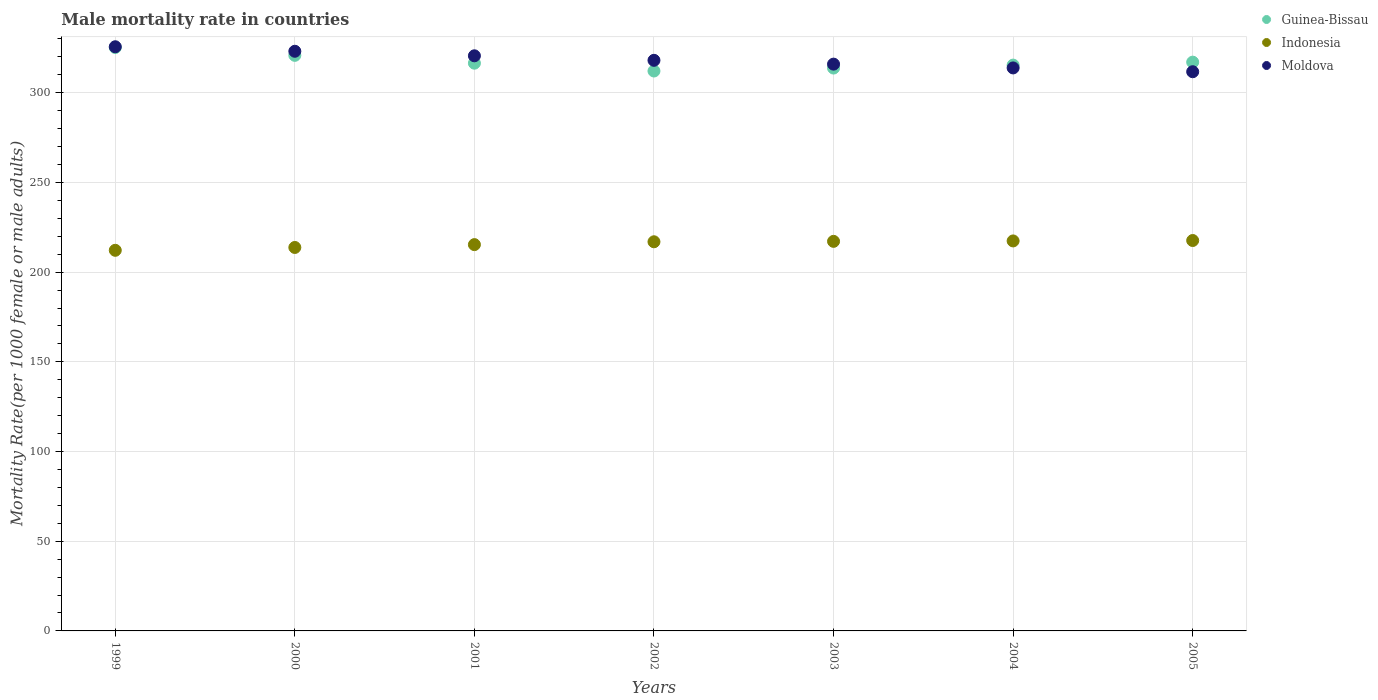Is the number of dotlines equal to the number of legend labels?
Provide a succinct answer. Yes. What is the male mortality rate in Indonesia in 2005?
Ensure brevity in your answer.  217.65. Across all years, what is the maximum male mortality rate in Indonesia?
Provide a short and direct response. 217.65. Across all years, what is the minimum male mortality rate in Indonesia?
Keep it short and to the point. 212.19. What is the total male mortality rate in Indonesia in the graph?
Provide a succinct answer. 1510.49. What is the difference between the male mortality rate in Guinea-Bissau in 2001 and that in 2005?
Provide a succinct answer. -0.57. What is the difference between the male mortality rate in Indonesia in 2004 and the male mortality rate in Moldova in 2001?
Offer a very short reply. -103.21. What is the average male mortality rate in Moldova per year?
Keep it short and to the point. 318.44. In the year 2000, what is the difference between the male mortality rate in Moldova and male mortality rate in Guinea-Bissau?
Provide a succinct answer. 2.27. What is the ratio of the male mortality rate in Moldova in 2002 to that in 2004?
Your answer should be very brief. 1.01. Is the difference between the male mortality rate in Moldova in 2002 and 2004 greater than the difference between the male mortality rate in Guinea-Bissau in 2002 and 2004?
Provide a short and direct response. Yes. What is the difference between the highest and the second highest male mortality rate in Guinea-Bissau?
Ensure brevity in your answer.  4.37. What is the difference between the highest and the lowest male mortality rate in Guinea-Bissau?
Your answer should be compact. 13.1. In how many years, is the male mortality rate in Indonesia greater than the average male mortality rate in Indonesia taken over all years?
Ensure brevity in your answer.  4. Is the sum of the male mortality rate in Moldova in 2004 and 2005 greater than the maximum male mortality rate in Guinea-Bissau across all years?
Provide a short and direct response. Yes. Does the male mortality rate in Indonesia monotonically increase over the years?
Provide a short and direct response. Yes. What is the difference between two consecutive major ticks on the Y-axis?
Ensure brevity in your answer.  50. Does the graph contain any zero values?
Offer a terse response. No. How are the legend labels stacked?
Make the answer very short. Vertical. What is the title of the graph?
Offer a terse response. Male mortality rate in countries. Does "South Sudan" appear as one of the legend labels in the graph?
Your answer should be compact. No. What is the label or title of the Y-axis?
Provide a succinct answer. Mortality Rate(per 1000 female or male adults). What is the Mortality Rate(per 1000 female or male adults) of Guinea-Bissau in 1999?
Provide a short and direct response. 325.23. What is the Mortality Rate(per 1000 female or male adults) in Indonesia in 1999?
Provide a succinct answer. 212.19. What is the Mortality Rate(per 1000 female or male adults) of Moldova in 1999?
Your answer should be very brief. 325.66. What is the Mortality Rate(per 1000 female or male adults) in Guinea-Bissau in 2000?
Provide a succinct answer. 320.87. What is the Mortality Rate(per 1000 female or male adults) in Indonesia in 2000?
Your response must be concise. 213.77. What is the Mortality Rate(per 1000 female or male adults) in Moldova in 2000?
Your answer should be compact. 323.14. What is the Mortality Rate(per 1000 female or male adults) in Guinea-Bissau in 2001?
Keep it short and to the point. 316.5. What is the Mortality Rate(per 1000 female or male adults) of Indonesia in 2001?
Provide a succinct answer. 215.36. What is the Mortality Rate(per 1000 female or male adults) of Moldova in 2001?
Ensure brevity in your answer.  320.62. What is the Mortality Rate(per 1000 female or male adults) in Guinea-Bissau in 2002?
Your answer should be very brief. 312.14. What is the Mortality Rate(per 1000 female or male adults) of Indonesia in 2002?
Offer a terse response. 216.94. What is the Mortality Rate(per 1000 female or male adults) in Moldova in 2002?
Make the answer very short. 318.1. What is the Mortality Rate(per 1000 female or male adults) in Guinea-Bissau in 2003?
Give a very brief answer. 313.79. What is the Mortality Rate(per 1000 female or male adults) in Indonesia in 2003?
Provide a succinct answer. 217.18. What is the Mortality Rate(per 1000 female or male adults) of Moldova in 2003?
Ensure brevity in your answer.  315.98. What is the Mortality Rate(per 1000 female or male adults) of Guinea-Bissau in 2004?
Your response must be concise. 315.43. What is the Mortality Rate(per 1000 female or male adults) in Indonesia in 2004?
Give a very brief answer. 217.41. What is the Mortality Rate(per 1000 female or male adults) of Moldova in 2004?
Offer a terse response. 313.86. What is the Mortality Rate(per 1000 female or male adults) of Guinea-Bissau in 2005?
Your response must be concise. 317.08. What is the Mortality Rate(per 1000 female or male adults) in Indonesia in 2005?
Your answer should be compact. 217.65. What is the Mortality Rate(per 1000 female or male adults) of Moldova in 2005?
Your answer should be very brief. 311.74. Across all years, what is the maximum Mortality Rate(per 1000 female or male adults) in Guinea-Bissau?
Your answer should be compact. 325.23. Across all years, what is the maximum Mortality Rate(per 1000 female or male adults) in Indonesia?
Your response must be concise. 217.65. Across all years, what is the maximum Mortality Rate(per 1000 female or male adults) in Moldova?
Make the answer very short. 325.66. Across all years, what is the minimum Mortality Rate(per 1000 female or male adults) in Guinea-Bissau?
Make the answer very short. 312.14. Across all years, what is the minimum Mortality Rate(per 1000 female or male adults) in Indonesia?
Offer a very short reply. 212.19. Across all years, what is the minimum Mortality Rate(per 1000 female or male adults) in Moldova?
Your answer should be compact. 311.74. What is the total Mortality Rate(per 1000 female or male adults) of Guinea-Bissau in the graph?
Offer a very short reply. 2221.04. What is the total Mortality Rate(per 1000 female or male adults) in Indonesia in the graph?
Provide a succinct answer. 1510.49. What is the total Mortality Rate(per 1000 female or male adults) in Moldova in the graph?
Ensure brevity in your answer.  2229.11. What is the difference between the Mortality Rate(per 1000 female or male adults) of Guinea-Bissau in 1999 and that in 2000?
Ensure brevity in your answer.  4.37. What is the difference between the Mortality Rate(per 1000 female or male adults) in Indonesia in 1999 and that in 2000?
Provide a short and direct response. -1.58. What is the difference between the Mortality Rate(per 1000 female or male adults) of Moldova in 1999 and that in 2000?
Give a very brief answer. 2.52. What is the difference between the Mortality Rate(per 1000 female or male adults) of Guinea-Bissau in 1999 and that in 2001?
Make the answer very short. 8.73. What is the difference between the Mortality Rate(per 1000 female or male adults) in Indonesia in 1999 and that in 2001?
Provide a short and direct response. -3.17. What is the difference between the Mortality Rate(per 1000 female or male adults) of Moldova in 1999 and that in 2001?
Give a very brief answer. 5.04. What is the difference between the Mortality Rate(per 1000 female or male adults) in Guinea-Bissau in 1999 and that in 2002?
Make the answer very short. 13.1. What is the difference between the Mortality Rate(per 1000 female or male adults) in Indonesia in 1999 and that in 2002?
Provide a succinct answer. -4.76. What is the difference between the Mortality Rate(per 1000 female or male adults) in Moldova in 1999 and that in 2002?
Make the answer very short. 7.57. What is the difference between the Mortality Rate(per 1000 female or male adults) of Guinea-Bissau in 1999 and that in 2003?
Make the answer very short. 11.45. What is the difference between the Mortality Rate(per 1000 female or male adults) in Indonesia in 1999 and that in 2003?
Your answer should be very brief. -4.99. What is the difference between the Mortality Rate(per 1000 female or male adults) of Moldova in 1999 and that in 2003?
Offer a very short reply. 9.69. What is the difference between the Mortality Rate(per 1000 female or male adults) in Guinea-Bissau in 1999 and that in 2004?
Give a very brief answer. 9.8. What is the difference between the Mortality Rate(per 1000 female or male adults) in Indonesia in 1999 and that in 2004?
Make the answer very short. -5.23. What is the difference between the Mortality Rate(per 1000 female or male adults) of Moldova in 1999 and that in 2004?
Your response must be concise. 11.8. What is the difference between the Mortality Rate(per 1000 female or male adults) of Guinea-Bissau in 1999 and that in 2005?
Keep it short and to the point. 8.15. What is the difference between the Mortality Rate(per 1000 female or male adults) of Indonesia in 1999 and that in 2005?
Offer a very short reply. -5.46. What is the difference between the Mortality Rate(per 1000 female or male adults) of Moldova in 1999 and that in 2005?
Your answer should be very brief. 13.92. What is the difference between the Mortality Rate(per 1000 female or male adults) in Guinea-Bissau in 2000 and that in 2001?
Provide a short and direct response. 4.37. What is the difference between the Mortality Rate(per 1000 female or male adults) in Indonesia in 2000 and that in 2001?
Provide a succinct answer. -1.59. What is the difference between the Mortality Rate(per 1000 female or male adults) of Moldova in 2000 and that in 2001?
Offer a terse response. 2.52. What is the difference between the Mortality Rate(per 1000 female or male adults) of Guinea-Bissau in 2000 and that in 2002?
Your response must be concise. 8.73. What is the difference between the Mortality Rate(per 1000 female or male adults) of Indonesia in 2000 and that in 2002?
Offer a terse response. -3.17. What is the difference between the Mortality Rate(per 1000 female or male adults) in Moldova in 2000 and that in 2002?
Your answer should be compact. 5.04. What is the difference between the Mortality Rate(per 1000 female or male adults) of Guinea-Bissau in 2000 and that in 2003?
Your response must be concise. 7.08. What is the difference between the Mortality Rate(per 1000 female or male adults) of Indonesia in 2000 and that in 2003?
Offer a terse response. -3.41. What is the difference between the Mortality Rate(per 1000 female or male adults) of Moldova in 2000 and that in 2003?
Ensure brevity in your answer.  7.16. What is the difference between the Mortality Rate(per 1000 female or male adults) in Guinea-Bissau in 2000 and that in 2004?
Provide a short and direct response. 5.44. What is the difference between the Mortality Rate(per 1000 female or male adults) in Indonesia in 2000 and that in 2004?
Your answer should be compact. -3.64. What is the difference between the Mortality Rate(per 1000 female or male adults) of Moldova in 2000 and that in 2004?
Provide a short and direct response. 9.28. What is the difference between the Mortality Rate(per 1000 female or male adults) in Guinea-Bissau in 2000 and that in 2005?
Ensure brevity in your answer.  3.79. What is the difference between the Mortality Rate(per 1000 female or male adults) in Indonesia in 2000 and that in 2005?
Provide a succinct answer. -3.88. What is the difference between the Mortality Rate(per 1000 female or male adults) in Moldova in 2000 and that in 2005?
Keep it short and to the point. 11.4. What is the difference between the Mortality Rate(per 1000 female or male adults) of Guinea-Bissau in 2001 and that in 2002?
Offer a very short reply. 4.37. What is the difference between the Mortality Rate(per 1000 female or male adults) of Indonesia in 2001 and that in 2002?
Ensure brevity in your answer.  -1.58. What is the difference between the Mortality Rate(per 1000 female or male adults) of Moldova in 2001 and that in 2002?
Ensure brevity in your answer.  2.52. What is the difference between the Mortality Rate(per 1000 female or male adults) in Guinea-Bissau in 2001 and that in 2003?
Your answer should be very brief. 2.72. What is the difference between the Mortality Rate(per 1000 female or male adults) in Indonesia in 2001 and that in 2003?
Provide a succinct answer. -1.82. What is the difference between the Mortality Rate(per 1000 female or male adults) in Moldova in 2001 and that in 2003?
Your response must be concise. 4.64. What is the difference between the Mortality Rate(per 1000 female or male adults) in Guinea-Bissau in 2001 and that in 2004?
Your answer should be very brief. 1.07. What is the difference between the Mortality Rate(per 1000 female or male adults) in Indonesia in 2001 and that in 2004?
Give a very brief answer. -2.06. What is the difference between the Mortality Rate(per 1000 female or male adults) in Moldova in 2001 and that in 2004?
Offer a terse response. 6.76. What is the difference between the Mortality Rate(per 1000 female or male adults) in Guinea-Bissau in 2001 and that in 2005?
Offer a terse response. -0.57. What is the difference between the Mortality Rate(per 1000 female or male adults) in Indonesia in 2001 and that in 2005?
Provide a succinct answer. -2.29. What is the difference between the Mortality Rate(per 1000 female or male adults) of Moldova in 2001 and that in 2005?
Give a very brief answer. 8.88. What is the difference between the Mortality Rate(per 1000 female or male adults) in Guinea-Bissau in 2002 and that in 2003?
Offer a very short reply. -1.65. What is the difference between the Mortality Rate(per 1000 female or male adults) of Indonesia in 2002 and that in 2003?
Provide a succinct answer. -0.23. What is the difference between the Mortality Rate(per 1000 female or male adults) in Moldova in 2002 and that in 2003?
Provide a short and direct response. 2.12. What is the difference between the Mortality Rate(per 1000 female or male adults) of Guinea-Bissau in 2002 and that in 2004?
Give a very brief answer. -3.29. What is the difference between the Mortality Rate(per 1000 female or male adults) in Indonesia in 2002 and that in 2004?
Make the answer very short. -0.47. What is the difference between the Mortality Rate(per 1000 female or male adults) of Moldova in 2002 and that in 2004?
Offer a terse response. 4.24. What is the difference between the Mortality Rate(per 1000 female or male adults) of Guinea-Bissau in 2002 and that in 2005?
Your answer should be compact. -4.94. What is the difference between the Mortality Rate(per 1000 female or male adults) in Indonesia in 2002 and that in 2005?
Provide a succinct answer. -0.71. What is the difference between the Mortality Rate(per 1000 female or male adults) of Moldova in 2002 and that in 2005?
Provide a short and direct response. 6.36. What is the difference between the Mortality Rate(per 1000 female or male adults) of Guinea-Bissau in 2003 and that in 2004?
Your response must be concise. -1.65. What is the difference between the Mortality Rate(per 1000 female or male adults) in Indonesia in 2003 and that in 2004?
Your answer should be very brief. -0.24. What is the difference between the Mortality Rate(per 1000 female or male adults) of Moldova in 2003 and that in 2004?
Ensure brevity in your answer.  2.12. What is the difference between the Mortality Rate(per 1000 female or male adults) of Guinea-Bissau in 2003 and that in 2005?
Keep it short and to the point. -3.29. What is the difference between the Mortality Rate(per 1000 female or male adults) in Indonesia in 2003 and that in 2005?
Offer a terse response. -0.47. What is the difference between the Mortality Rate(per 1000 female or male adults) of Moldova in 2003 and that in 2005?
Give a very brief answer. 4.24. What is the difference between the Mortality Rate(per 1000 female or male adults) of Guinea-Bissau in 2004 and that in 2005?
Give a very brief answer. -1.65. What is the difference between the Mortality Rate(per 1000 female or male adults) in Indonesia in 2004 and that in 2005?
Keep it short and to the point. -0.23. What is the difference between the Mortality Rate(per 1000 female or male adults) in Moldova in 2004 and that in 2005?
Your answer should be very brief. 2.12. What is the difference between the Mortality Rate(per 1000 female or male adults) in Guinea-Bissau in 1999 and the Mortality Rate(per 1000 female or male adults) in Indonesia in 2000?
Make the answer very short. 111.46. What is the difference between the Mortality Rate(per 1000 female or male adults) of Guinea-Bissau in 1999 and the Mortality Rate(per 1000 female or male adults) of Moldova in 2000?
Your answer should be compact. 2.09. What is the difference between the Mortality Rate(per 1000 female or male adults) in Indonesia in 1999 and the Mortality Rate(per 1000 female or male adults) in Moldova in 2000?
Make the answer very short. -110.96. What is the difference between the Mortality Rate(per 1000 female or male adults) in Guinea-Bissau in 1999 and the Mortality Rate(per 1000 female or male adults) in Indonesia in 2001?
Your answer should be compact. 109.88. What is the difference between the Mortality Rate(per 1000 female or male adults) in Guinea-Bissau in 1999 and the Mortality Rate(per 1000 female or male adults) in Moldova in 2001?
Provide a succinct answer. 4.61. What is the difference between the Mortality Rate(per 1000 female or male adults) of Indonesia in 1999 and the Mortality Rate(per 1000 female or male adults) of Moldova in 2001?
Make the answer very short. -108.44. What is the difference between the Mortality Rate(per 1000 female or male adults) of Guinea-Bissau in 1999 and the Mortality Rate(per 1000 female or male adults) of Indonesia in 2002?
Keep it short and to the point. 108.29. What is the difference between the Mortality Rate(per 1000 female or male adults) of Guinea-Bissau in 1999 and the Mortality Rate(per 1000 female or male adults) of Moldova in 2002?
Offer a terse response. 7.13. What is the difference between the Mortality Rate(per 1000 female or male adults) of Indonesia in 1999 and the Mortality Rate(per 1000 female or male adults) of Moldova in 2002?
Your answer should be compact. -105.91. What is the difference between the Mortality Rate(per 1000 female or male adults) of Guinea-Bissau in 1999 and the Mortality Rate(per 1000 female or male adults) of Indonesia in 2003?
Offer a terse response. 108.06. What is the difference between the Mortality Rate(per 1000 female or male adults) in Guinea-Bissau in 1999 and the Mortality Rate(per 1000 female or male adults) in Moldova in 2003?
Keep it short and to the point. 9.25. What is the difference between the Mortality Rate(per 1000 female or male adults) of Indonesia in 1999 and the Mortality Rate(per 1000 female or male adults) of Moldova in 2003?
Offer a terse response. -103.79. What is the difference between the Mortality Rate(per 1000 female or male adults) in Guinea-Bissau in 1999 and the Mortality Rate(per 1000 female or male adults) in Indonesia in 2004?
Offer a very short reply. 107.82. What is the difference between the Mortality Rate(per 1000 female or male adults) in Guinea-Bissau in 1999 and the Mortality Rate(per 1000 female or male adults) in Moldova in 2004?
Provide a succinct answer. 11.37. What is the difference between the Mortality Rate(per 1000 female or male adults) of Indonesia in 1999 and the Mortality Rate(per 1000 female or male adults) of Moldova in 2004?
Your response must be concise. -101.67. What is the difference between the Mortality Rate(per 1000 female or male adults) in Guinea-Bissau in 1999 and the Mortality Rate(per 1000 female or male adults) in Indonesia in 2005?
Your answer should be very brief. 107.59. What is the difference between the Mortality Rate(per 1000 female or male adults) of Guinea-Bissau in 1999 and the Mortality Rate(per 1000 female or male adults) of Moldova in 2005?
Your answer should be very brief. 13.49. What is the difference between the Mortality Rate(per 1000 female or male adults) of Indonesia in 1999 and the Mortality Rate(per 1000 female or male adults) of Moldova in 2005?
Keep it short and to the point. -99.55. What is the difference between the Mortality Rate(per 1000 female or male adults) of Guinea-Bissau in 2000 and the Mortality Rate(per 1000 female or male adults) of Indonesia in 2001?
Your answer should be compact. 105.51. What is the difference between the Mortality Rate(per 1000 female or male adults) of Guinea-Bissau in 2000 and the Mortality Rate(per 1000 female or male adults) of Moldova in 2001?
Ensure brevity in your answer.  0.25. What is the difference between the Mortality Rate(per 1000 female or male adults) of Indonesia in 2000 and the Mortality Rate(per 1000 female or male adults) of Moldova in 2001?
Your response must be concise. -106.85. What is the difference between the Mortality Rate(per 1000 female or male adults) in Guinea-Bissau in 2000 and the Mortality Rate(per 1000 female or male adults) in Indonesia in 2002?
Your answer should be very brief. 103.93. What is the difference between the Mortality Rate(per 1000 female or male adults) of Guinea-Bissau in 2000 and the Mortality Rate(per 1000 female or male adults) of Moldova in 2002?
Ensure brevity in your answer.  2.77. What is the difference between the Mortality Rate(per 1000 female or male adults) in Indonesia in 2000 and the Mortality Rate(per 1000 female or male adults) in Moldova in 2002?
Offer a terse response. -104.33. What is the difference between the Mortality Rate(per 1000 female or male adults) of Guinea-Bissau in 2000 and the Mortality Rate(per 1000 female or male adults) of Indonesia in 2003?
Your answer should be very brief. 103.69. What is the difference between the Mortality Rate(per 1000 female or male adults) of Guinea-Bissau in 2000 and the Mortality Rate(per 1000 female or male adults) of Moldova in 2003?
Ensure brevity in your answer.  4.89. What is the difference between the Mortality Rate(per 1000 female or male adults) of Indonesia in 2000 and the Mortality Rate(per 1000 female or male adults) of Moldova in 2003?
Ensure brevity in your answer.  -102.21. What is the difference between the Mortality Rate(per 1000 female or male adults) of Guinea-Bissau in 2000 and the Mortality Rate(per 1000 female or male adults) of Indonesia in 2004?
Provide a short and direct response. 103.46. What is the difference between the Mortality Rate(per 1000 female or male adults) in Guinea-Bissau in 2000 and the Mortality Rate(per 1000 female or male adults) in Moldova in 2004?
Your response must be concise. 7.01. What is the difference between the Mortality Rate(per 1000 female or male adults) in Indonesia in 2000 and the Mortality Rate(per 1000 female or male adults) in Moldova in 2004?
Your answer should be very brief. -100.09. What is the difference between the Mortality Rate(per 1000 female or male adults) of Guinea-Bissau in 2000 and the Mortality Rate(per 1000 female or male adults) of Indonesia in 2005?
Provide a short and direct response. 103.22. What is the difference between the Mortality Rate(per 1000 female or male adults) in Guinea-Bissau in 2000 and the Mortality Rate(per 1000 female or male adults) in Moldova in 2005?
Make the answer very short. 9.13. What is the difference between the Mortality Rate(per 1000 female or male adults) in Indonesia in 2000 and the Mortality Rate(per 1000 female or male adults) in Moldova in 2005?
Ensure brevity in your answer.  -97.97. What is the difference between the Mortality Rate(per 1000 female or male adults) in Guinea-Bissau in 2001 and the Mortality Rate(per 1000 female or male adults) in Indonesia in 2002?
Offer a terse response. 99.56. What is the difference between the Mortality Rate(per 1000 female or male adults) of Guinea-Bissau in 2001 and the Mortality Rate(per 1000 female or male adults) of Moldova in 2002?
Offer a terse response. -1.59. What is the difference between the Mortality Rate(per 1000 female or male adults) of Indonesia in 2001 and the Mortality Rate(per 1000 female or male adults) of Moldova in 2002?
Your answer should be very brief. -102.74. What is the difference between the Mortality Rate(per 1000 female or male adults) of Guinea-Bissau in 2001 and the Mortality Rate(per 1000 female or male adults) of Indonesia in 2003?
Your response must be concise. 99.33. What is the difference between the Mortality Rate(per 1000 female or male adults) in Guinea-Bissau in 2001 and the Mortality Rate(per 1000 female or male adults) in Moldova in 2003?
Offer a very short reply. 0.52. What is the difference between the Mortality Rate(per 1000 female or male adults) in Indonesia in 2001 and the Mortality Rate(per 1000 female or male adults) in Moldova in 2003?
Give a very brief answer. -100.62. What is the difference between the Mortality Rate(per 1000 female or male adults) of Guinea-Bissau in 2001 and the Mortality Rate(per 1000 female or male adults) of Indonesia in 2004?
Provide a succinct answer. 99.09. What is the difference between the Mortality Rate(per 1000 female or male adults) in Guinea-Bissau in 2001 and the Mortality Rate(per 1000 female or male adults) in Moldova in 2004?
Your answer should be compact. 2.64. What is the difference between the Mortality Rate(per 1000 female or male adults) in Indonesia in 2001 and the Mortality Rate(per 1000 female or male adults) in Moldova in 2004?
Offer a terse response. -98.5. What is the difference between the Mortality Rate(per 1000 female or male adults) of Guinea-Bissau in 2001 and the Mortality Rate(per 1000 female or male adults) of Indonesia in 2005?
Offer a very short reply. 98.86. What is the difference between the Mortality Rate(per 1000 female or male adults) in Guinea-Bissau in 2001 and the Mortality Rate(per 1000 female or male adults) in Moldova in 2005?
Your answer should be very brief. 4.76. What is the difference between the Mortality Rate(per 1000 female or male adults) in Indonesia in 2001 and the Mortality Rate(per 1000 female or male adults) in Moldova in 2005?
Provide a succinct answer. -96.38. What is the difference between the Mortality Rate(per 1000 female or male adults) in Guinea-Bissau in 2002 and the Mortality Rate(per 1000 female or male adults) in Indonesia in 2003?
Offer a very short reply. 94.96. What is the difference between the Mortality Rate(per 1000 female or male adults) of Guinea-Bissau in 2002 and the Mortality Rate(per 1000 female or male adults) of Moldova in 2003?
Offer a very short reply. -3.84. What is the difference between the Mortality Rate(per 1000 female or male adults) of Indonesia in 2002 and the Mortality Rate(per 1000 female or male adults) of Moldova in 2003?
Provide a short and direct response. -99.04. What is the difference between the Mortality Rate(per 1000 female or male adults) in Guinea-Bissau in 2002 and the Mortality Rate(per 1000 female or male adults) in Indonesia in 2004?
Offer a terse response. 94.73. What is the difference between the Mortality Rate(per 1000 female or male adults) of Guinea-Bissau in 2002 and the Mortality Rate(per 1000 female or male adults) of Moldova in 2004?
Keep it short and to the point. -1.72. What is the difference between the Mortality Rate(per 1000 female or male adults) of Indonesia in 2002 and the Mortality Rate(per 1000 female or male adults) of Moldova in 2004?
Offer a terse response. -96.92. What is the difference between the Mortality Rate(per 1000 female or male adults) of Guinea-Bissau in 2002 and the Mortality Rate(per 1000 female or male adults) of Indonesia in 2005?
Your response must be concise. 94.49. What is the difference between the Mortality Rate(per 1000 female or male adults) in Guinea-Bissau in 2002 and the Mortality Rate(per 1000 female or male adults) in Moldova in 2005?
Your answer should be very brief. 0.4. What is the difference between the Mortality Rate(per 1000 female or male adults) of Indonesia in 2002 and the Mortality Rate(per 1000 female or male adults) of Moldova in 2005?
Give a very brief answer. -94.8. What is the difference between the Mortality Rate(per 1000 female or male adults) in Guinea-Bissau in 2003 and the Mortality Rate(per 1000 female or male adults) in Indonesia in 2004?
Provide a succinct answer. 96.37. What is the difference between the Mortality Rate(per 1000 female or male adults) in Guinea-Bissau in 2003 and the Mortality Rate(per 1000 female or male adults) in Moldova in 2004?
Ensure brevity in your answer.  -0.07. What is the difference between the Mortality Rate(per 1000 female or male adults) in Indonesia in 2003 and the Mortality Rate(per 1000 female or male adults) in Moldova in 2004?
Ensure brevity in your answer.  -96.68. What is the difference between the Mortality Rate(per 1000 female or male adults) in Guinea-Bissau in 2003 and the Mortality Rate(per 1000 female or male adults) in Indonesia in 2005?
Give a very brief answer. 96.14. What is the difference between the Mortality Rate(per 1000 female or male adults) in Guinea-Bissau in 2003 and the Mortality Rate(per 1000 female or male adults) in Moldova in 2005?
Offer a terse response. 2.05. What is the difference between the Mortality Rate(per 1000 female or male adults) in Indonesia in 2003 and the Mortality Rate(per 1000 female or male adults) in Moldova in 2005?
Offer a very short reply. -94.56. What is the difference between the Mortality Rate(per 1000 female or male adults) in Guinea-Bissau in 2004 and the Mortality Rate(per 1000 female or male adults) in Indonesia in 2005?
Provide a short and direct response. 97.79. What is the difference between the Mortality Rate(per 1000 female or male adults) of Guinea-Bissau in 2004 and the Mortality Rate(per 1000 female or male adults) of Moldova in 2005?
Provide a short and direct response. 3.69. What is the difference between the Mortality Rate(per 1000 female or male adults) of Indonesia in 2004 and the Mortality Rate(per 1000 female or male adults) of Moldova in 2005?
Give a very brief answer. -94.33. What is the average Mortality Rate(per 1000 female or male adults) in Guinea-Bissau per year?
Your answer should be very brief. 317.29. What is the average Mortality Rate(per 1000 female or male adults) in Indonesia per year?
Ensure brevity in your answer.  215.78. What is the average Mortality Rate(per 1000 female or male adults) in Moldova per year?
Offer a very short reply. 318.44. In the year 1999, what is the difference between the Mortality Rate(per 1000 female or male adults) of Guinea-Bissau and Mortality Rate(per 1000 female or male adults) of Indonesia?
Your answer should be compact. 113.05. In the year 1999, what is the difference between the Mortality Rate(per 1000 female or male adults) in Guinea-Bissau and Mortality Rate(per 1000 female or male adults) in Moldova?
Offer a very short reply. -0.43. In the year 1999, what is the difference between the Mortality Rate(per 1000 female or male adults) of Indonesia and Mortality Rate(per 1000 female or male adults) of Moldova?
Ensure brevity in your answer.  -113.48. In the year 2000, what is the difference between the Mortality Rate(per 1000 female or male adults) of Guinea-Bissau and Mortality Rate(per 1000 female or male adults) of Indonesia?
Provide a short and direct response. 107.1. In the year 2000, what is the difference between the Mortality Rate(per 1000 female or male adults) of Guinea-Bissau and Mortality Rate(per 1000 female or male adults) of Moldova?
Make the answer very short. -2.27. In the year 2000, what is the difference between the Mortality Rate(per 1000 female or male adults) of Indonesia and Mortality Rate(per 1000 female or male adults) of Moldova?
Ensure brevity in your answer.  -109.37. In the year 2001, what is the difference between the Mortality Rate(per 1000 female or male adults) in Guinea-Bissau and Mortality Rate(per 1000 female or male adults) in Indonesia?
Ensure brevity in your answer.  101.15. In the year 2001, what is the difference between the Mortality Rate(per 1000 female or male adults) in Guinea-Bissau and Mortality Rate(per 1000 female or male adults) in Moldova?
Ensure brevity in your answer.  -4.12. In the year 2001, what is the difference between the Mortality Rate(per 1000 female or male adults) of Indonesia and Mortality Rate(per 1000 female or male adults) of Moldova?
Your answer should be compact. -105.26. In the year 2002, what is the difference between the Mortality Rate(per 1000 female or male adults) of Guinea-Bissau and Mortality Rate(per 1000 female or male adults) of Indonesia?
Your answer should be very brief. 95.2. In the year 2002, what is the difference between the Mortality Rate(per 1000 female or male adults) of Guinea-Bissau and Mortality Rate(per 1000 female or male adults) of Moldova?
Make the answer very short. -5.96. In the year 2002, what is the difference between the Mortality Rate(per 1000 female or male adults) of Indonesia and Mortality Rate(per 1000 female or male adults) of Moldova?
Your answer should be compact. -101.16. In the year 2003, what is the difference between the Mortality Rate(per 1000 female or male adults) in Guinea-Bissau and Mortality Rate(per 1000 female or male adults) in Indonesia?
Your answer should be compact. 96.61. In the year 2003, what is the difference between the Mortality Rate(per 1000 female or male adults) of Guinea-Bissau and Mortality Rate(per 1000 female or male adults) of Moldova?
Ensure brevity in your answer.  -2.19. In the year 2003, what is the difference between the Mortality Rate(per 1000 female or male adults) of Indonesia and Mortality Rate(per 1000 female or male adults) of Moldova?
Provide a succinct answer. -98.8. In the year 2004, what is the difference between the Mortality Rate(per 1000 female or male adults) of Guinea-Bissau and Mortality Rate(per 1000 female or male adults) of Indonesia?
Offer a very short reply. 98.02. In the year 2004, what is the difference between the Mortality Rate(per 1000 female or male adults) of Guinea-Bissau and Mortality Rate(per 1000 female or male adults) of Moldova?
Your answer should be compact. 1.57. In the year 2004, what is the difference between the Mortality Rate(per 1000 female or male adults) of Indonesia and Mortality Rate(per 1000 female or male adults) of Moldova?
Your answer should be compact. -96.45. In the year 2005, what is the difference between the Mortality Rate(per 1000 female or male adults) of Guinea-Bissau and Mortality Rate(per 1000 female or male adults) of Indonesia?
Offer a very short reply. 99.43. In the year 2005, what is the difference between the Mortality Rate(per 1000 female or male adults) in Guinea-Bissau and Mortality Rate(per 1000 female or male adults) in Moldova?
Keep it short and to the point. 5.34. In the year 2005, what is the difference between the Mortality Rate(per 1000 female or male adults) in Indonesia and Mortality Rate(per 1000 female or male adults) in Moldova?
Your answer should be very brief. -94.09. What is the ratio of the Mortality Rate(per 1000 female or male adults) of Guinea-Bissau in 1999 to that in 2000?
Ensure brevity in your answer.  1.01. What is the ratio of the Mortality Rate(per 1000 female or male adults) in Moldova in 1999 to that in 2000?
Your response must be concise. 1.01. What is the ratio of the Mortality Rate(per 1000 female or male adults) of Guinea-Bissau in 1999 to that in 2001?
Give a very brief answer. 1.03. What is the ratio of the Mortality Rate(per 1000 female or male adults) of Indonesia in 1999 to that in 2001?
Make the answer very short. 0.99. What is the ratio of the Mortality Rate(per 1000 female or male adults) in Moldova in 1999 to that in 2001?
Ensure brevity in your answer.  1.02. What is the ratio of the Mortality Rate(per 1000 female or male adults) of Guinea-Bissau in 1999 to that in 2002?
Your answer should be very brief. 1.04. What is the ratio of the Mortality Rate(per 1000 female or male adults) of Indonesia in 1999 to that in 2002?
Offer a very short reply. 0.98. What is the ratio of the Mortality Rate(per 1000 female or male adults) in Moldova in 1999 to that in 2002?
Your answer should be compact. 1.02. What is the ratio of the Mortality Rate(per 1000 female or male adults) in Guinea-Bissau in 1999 to that in 2003?
Give a very brief answer. 1.04. What is the ratio of the Mortality Rate(per 1000 female or male adults) in Indonesia in 1999 to that in 2003?
Give a very brief answer. 0.98. What is the ratio of the Mortality Rate(per 1000 female or male adults) in Moldova in 1999 to that in 2003?
Offer a terse response. 1.03. What is the ratio of the Mortality Rate(per 1000 female or male adults) of Guinea-Bissau in 1999 to that in 2004?
Your answer should be very brief. 1.03. What is the ratio of the Mortality Rate(per 1000 female or male adults) of Moldova in 1999 to that in 2004?
Ensure brevity in your answer.  1.04. What is the ratio of the Mortality Rate(per 1000 female or male adults) of Guinea-Bissau in 1999 to that in 2005?
Provide a short and direct response. 1.03. What is the ratio of the Mortality Rate(per 1000 female or male adults) of Indonesia in 1999 to that in 2005?
Offer a terse response. 0.97. What is the ratio of the Mortality Rate(per 1000 female or male adults) of Moldova in 1999 to that in 2005?
Your response must be concise. 1.04. What is the ratio of the Mortality Rate(per 1000 female or male adults) in Guinea-Bissau in 2000 to that in 2001?
Provide a succinct answer. 1.01. What is the ratio of the Mortality Rate(per 1000 female or male adults) in Moldova in 2000 to that in 2001?
Provide a succinct answer. 1.01. What is the ratio of the Mortality Rate(per 1000 female or male adults) of Guinea-Bissau in 2000 to that in 2002?
Offer a very short reply. 1.03. What is the ratio of the Mortality Rate(per 1000 female or male adults) in Indonesia in 2000 to that in 2002?
Keep it short and to the point. 0.99. What is the ratio of the Mortality Rate(per 1000 female or male adults) in Moldova in 2000 to that in 2002?
Provide a succinct answer. 1.02. What is the ratio of the Mortality Rate(per 1000 female or male adults) in Guinea-Bissau in 2000 to that in 2003?
Provide a short and direct response. 1.02. What is the ratio of the Mortality Rate(per 1000 female or male adults) in Indonesia in 2000 to that in 2003?
Offer a terse response. 0.98. What is the ratio of the Mortality Rate(per 1000 female or male adults) in Moldova in 2000 to that in 2003?
Offer a terse response. 1.02. What is the ratio of the Mortality Rate(per 1000 female or male adults) of Guinea-Bissau in 2000 to that in 2004?
Your answer should be very brief. 1.02. What is the ratio of the Mortality Rate(per 1000 female or male adults) in Indonesia in 2000 to that in 2004?
Offer a terse response. 0.98. What is the ratio of the Mortality Rate(per 1000 female or male adults) in Moldova in 2000 to that in 2004?
Give a very brief answer. 1.03. What is the ratio of the Mortality Rate(per 1000 female or male adults) in Indonesia in 2000 to that in 2005?
Keep it short and to the point. 0.98. What is the ratio of the Mortality Rate(per 1000 female or male adults) in Moldova in 2000 to that in 2005?
Make the answer very short. 1.04. What is the ratio of the Mortality Rate(per 1000 female or male adults) in Indonesia in 2001 to that in 2002?
Make the answer very short. 0.99. What is the ratio of the Mortality Rate(per 1000 female or male adults) in Moldova in 2001 to that in 2002?
Keep it short and to the point. 1.01. What is the ratio of the Mortality Rate(per 1000 female or male adults) in Guinea-Bissau in 2001 to that in 2003?
Give a very brief answer. 1.01. What is the ratio of the Mortality Rate(per 1000 female or male adults) of Indonesia in 2001 to that in 2003?
Ensure brevity in your answer.  0.99. What is the ratio of the Mortality Rate(per 1000 female or male adults) in Moldova in 2001 to that in 2003?
Your response must be concise. 1.01. What is the ratio of the Mortality Rate(per 1000 female or male adults) of Guinea-Bissau in 2001 to that in 2004?
Your response must be concise. 1. What is the ratio of the Mortality Rate(per 1000 female or male adults) in Moldova in 2001 to that in 2004?
Keep it short and to the point. 1.02. What is the ratio of the Mortality Rate(per 1000 female or male adults) in Indonesia in 2001 to that in 2005?
Your answer should be compact. 0.99. What is the ratio of the Mortality Rate(per 1000 female or male adults) of Moldova in 2001 to that in 2005?
Your answer should be very brief. 1.03. What is the ratio of the Mortality Rate(per 1000 female or male adults) of Moldova in 2002 to that in 2003?
Ensure brevity in your answer.  1.01. What is the ratio of the Mortality Rate(per 1000 female or male adults) in Indonesia in 2002 to that in 2004?
Offer a very short reply. 1. What is the ratio of the Mortality Rate(per 1000 female or male adults) in Moldova in 2002 to that in 2004?
Give a very brief answer. 1.01. What is the ratio of the Mortality Rate(per 1000 female or male adults) in Guinea-Bissau in 2002 to that in 2005?
Your response must be concise. 0.98. What is the ratio of the Mortality Rate(per 1000 female or male adults) of Indonesia in 2002 to that in 2005?
Provide a short and direct response. 1. What is the ratio of the Mortality Rate(per 1000 female or male adults) in Moldova in 2002 to that in 2005?
Provide a short and direct response. 1.02. What is the ratio of the Mortality Rate(per 1000 female or male adults) in Guinea-Bissau in 2003 to that in 2004?
Provide a short and direct response. 0.99. What is the ratio of the Mortality Rate(per 1000 female or male adults) in Moldova in 2003 to that in 2004?
Your answer should be very brief. 1.01. What is the ratio of the Mortality Rate(per 1000 female or male adults) in Moldova in 2003 to that in 2005?
Your answer should be very brief. 1.01. What is the ratio of the Mortality Rate(per 1000 female or male adults) of Indonesia in 2004 to that in 2005?
Give a very brief answer. 1. What is the ratio of the Mortality Rate(per 1000 female or male adults) in Moldova in 2004 to that in 2005?
Your response must be concise. 1.01. What is the difference between the highest and the second highest Mortality Rate(per 1000 female or male adults) in Guinea-Bissau?
Make the answer very short. 4.37. What is the difference between the highest and the second highest Mortality Rate(per 1000 female or male adults) in Indonesia?
Your response must be concise. 0.23. What is the difference between the highest and the second highest Mortality Rate(per 1000 female or male adults) of Moldova?
Ensure brevity in your answer.  2.52. What is the difference between the highest and the lowest Mortality Rate(per 1000 female or male adults) of Guinea-Bissau?
Offer a terse response. 13.1. What is the difference between the highest and the lowest Mortality Rate(per 1000 female or male adults) in Indonesia?
Offer a very short reply. 5.46. What is the difference between the highest and the lowest Mortality Rate(per 1000 female or male adults) in Moldova?
Give a very brief answer. 13.92. 